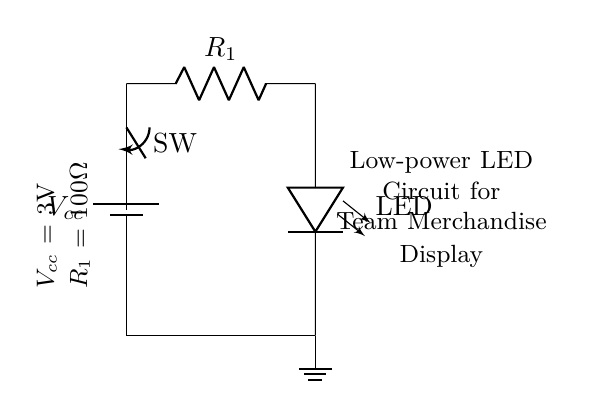What is the power supply voltage used in this circuit? The power supply voltage, labeled as Vcc, is indicated in the circuit diagram as 3V.
Answer: 3V What component is used to limit current in this circuit? The circuit includes a resistor, labeled as R1, which is specifically used to limit the current flowing to the LED.
Answer: R1 How many components are in this circuit? By counting the individual items, there are four main components: a battery, a resistor, an LED, and a switch.
Answer: Four What is the resistance value of the current limiting resistor? The resistor R1 has a specified resistance value of 100 ohms, which is detailed in the annotations of the circuit.
Answer: 100 ohms What is the purpose of the switch in this circuit? The switch, labeled as SW, allows the user to open or close the circuit, thereby controlling the flow of electricity to the LED for turning it on or off.
Answer: Control LED Why is a resistor necessary in this LED circuit? A resistor is necessary to limit the current to a safe level for the LED to prevent it from drawing too much current, which could damage the LED.
Answer: To protect LED 